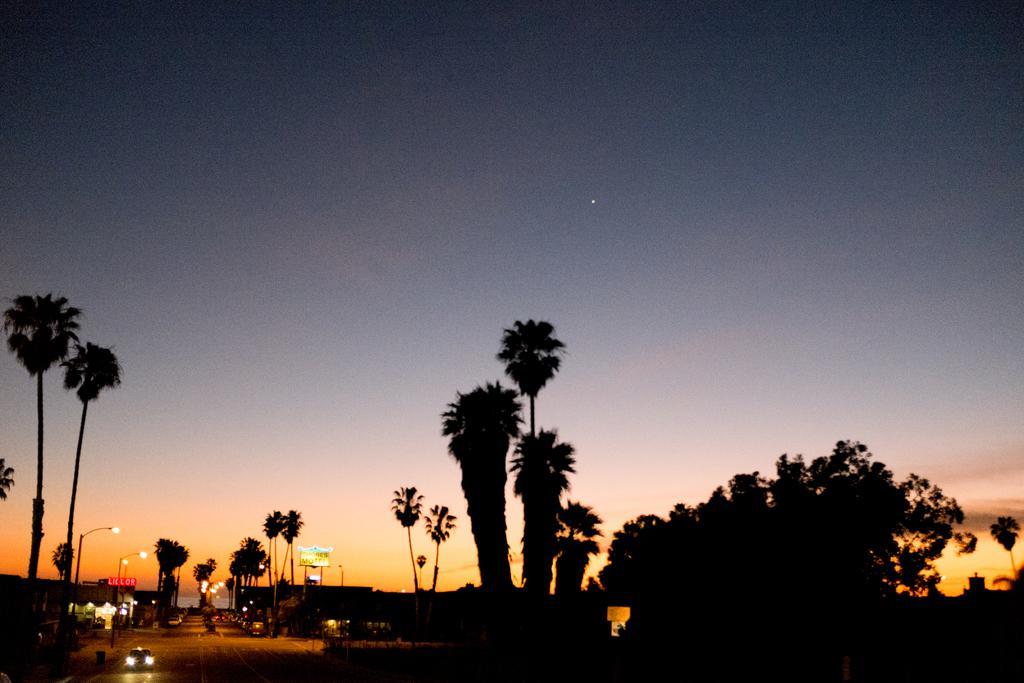Could you give a brief overview of what you see in this image? In this image we can see trees, road, vehicles on the road, light poles. At the top of the image there is sky. 